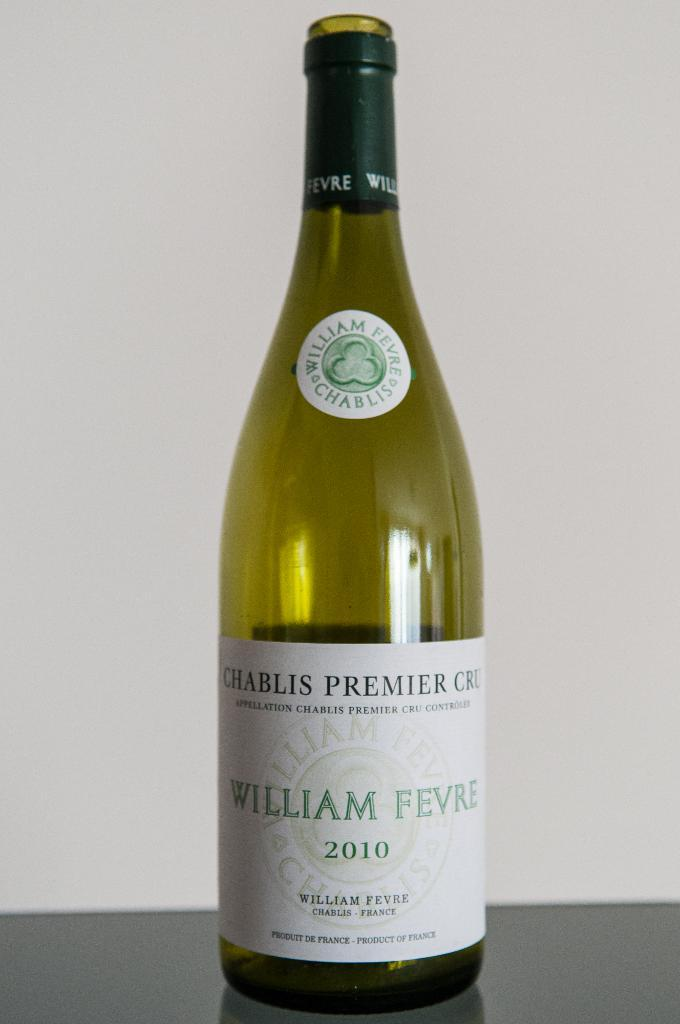<image>
Give a short and clear explanation of the subsequent image. Bottle of wine by William Fevre from 2010 on a table. 